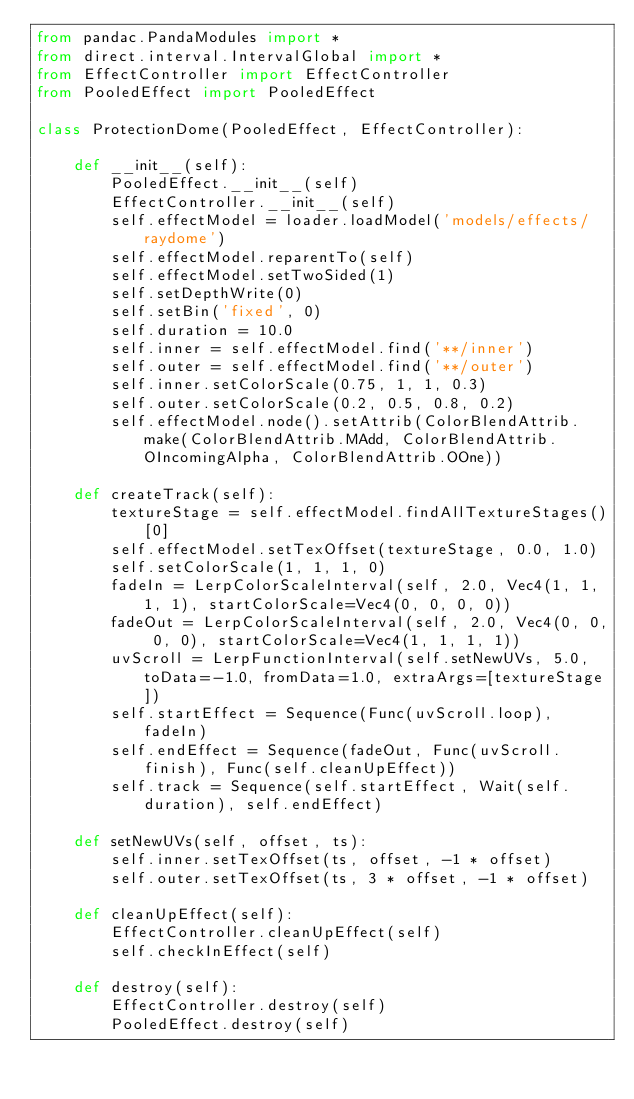Convert code to text. <code><loc_0><loc_0><loc_500><loc_500><_Python_>from pandac.PandaModules import *
from direct.interval.IntervalGlobal import *
from EffectController import EffectController
from PooledEffect import PooledEffect

class ProtectionDome(PooledEffect, EffectController):

    def __init__(self):
        PooledEffect.__init__(self)
        EffectController.__init__(self)
        self.effectModel = loader.loadModel('models/effects/raydome')
        self.effectModel.reparentTo(self)
        self.effectModel.setTwoSided(1)
        self.setDepthWrite(0)
        self.setBin('fixed', 0)
        self.duration = 10.0
        self.inner = self.effectModel.find('**/inner')
        self.outer = self.effectModel.find('**/outer')
        self.inner.setColorScale(0.75, 1, 1, 0.3)
        self.outer.setColorScale(0.2, 0.5, 0.8, 0.2)
        self.effectModel.node().setAttrib(ColorBlendAttrib.make(ColorBlendAttrib.MAdd, ColorBlendAttrib.OIncomingAlpha, ColorBlendAttrib.OOne))

    def createTrack(self):
        textureStage = self.effectModel.findAllTextureStages()[0]
        self.effectModel.setTexOffset(textureStage, 0.0, 1.0)
        self.setColorScale(1, 1, 1, 0)
        fadeIn = LerpColorScaleInterval(self, 2.0, Vec4(1, 1, 1, 1), startColorScale=Vec4(0, 0, 0, 0))
        fadeOut = LerpColorScaleInterval(self, 2.0, Vec4(0, 0, 0, 0), startColorScale=Vec4(1, 1, 1, 1))
        uvScroll = LerpFunctionInterval(self.setNewUVs, 5.0, toData=-1.0, fromData=1.0, extraArgs=[textureStage])
        self.startEffect = Sequence(Func(uvScroll.loop), fadeIn)
        self.endEffect = Sequence(fadeOut, Func(uvScroll.finish), Func(self.cleanUpEffect))
        self.track = Sequence(self.startEffect, Wait(self.duration), self.endEffect)

    def setNewUVs(self, offset, ts):
        self.inner.setTexOffset(ts, offset, -1 * offset)
        self.outer.setTexOffset(ts, 3 * offset, -1 * offset)

    def cleanUpEffect(self):
        EffectController.cleanUpEffect(self)
        self.checkInEffect(self)

    def destroy(self):
        EffectController.destroy(self)
        PooledEffect.destroy(self)</code> 